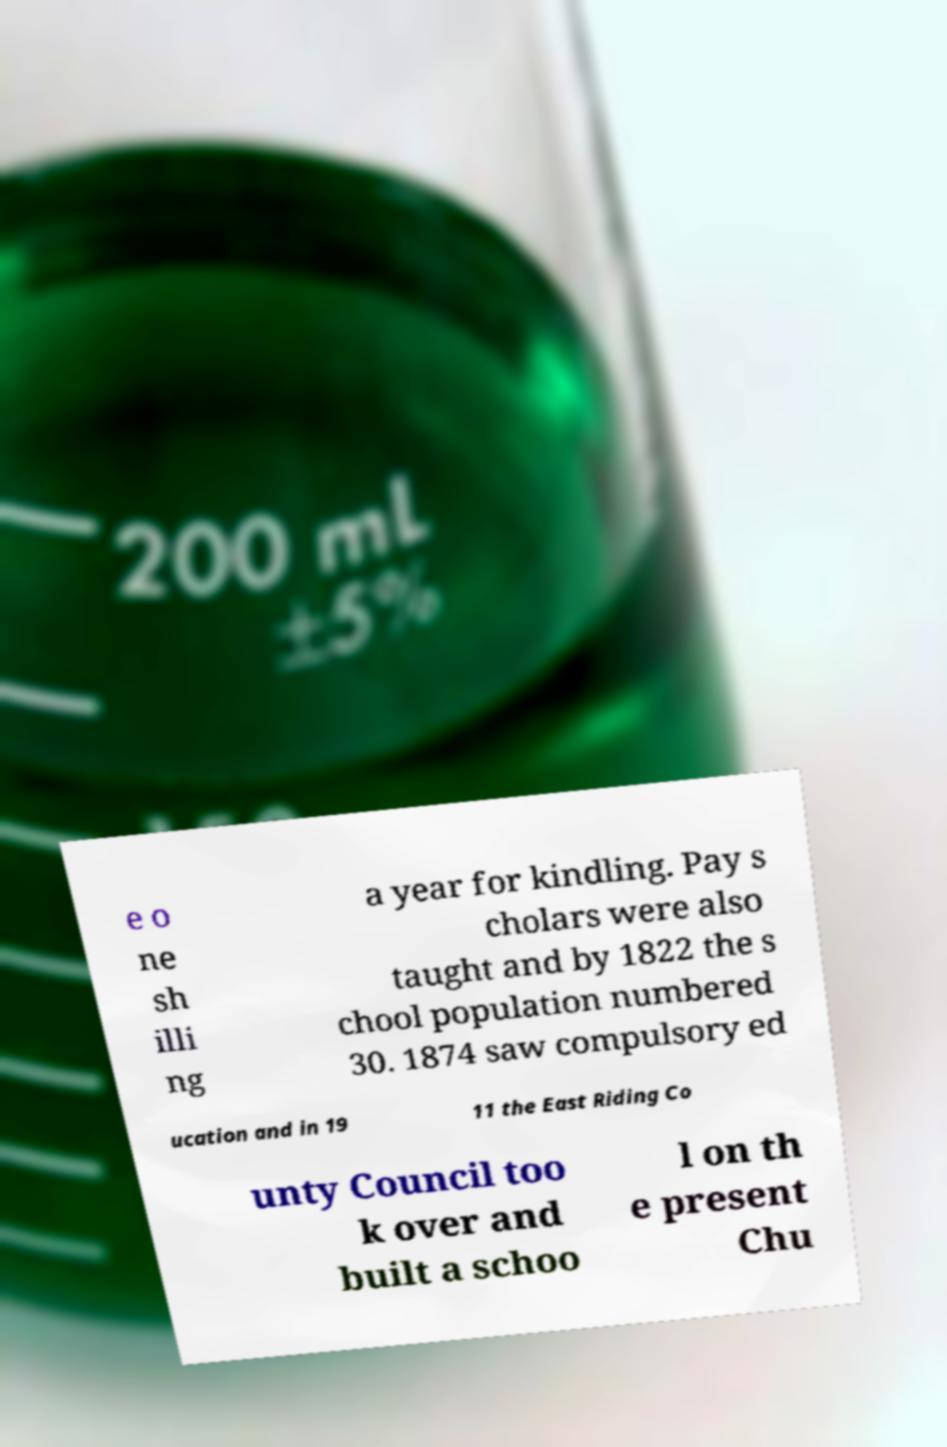For documentation purposes, I need the text within this image transcribed. Could you provide that? e o ne sh illi ng a year for kindling. Pay s cholars were also taught and by 1822 the s chool population numbered 30. 1874 saw compulsory ed ucation and in 19 11 the East Riding Co unty Council too k over and built a schoo l on th e present Chu 